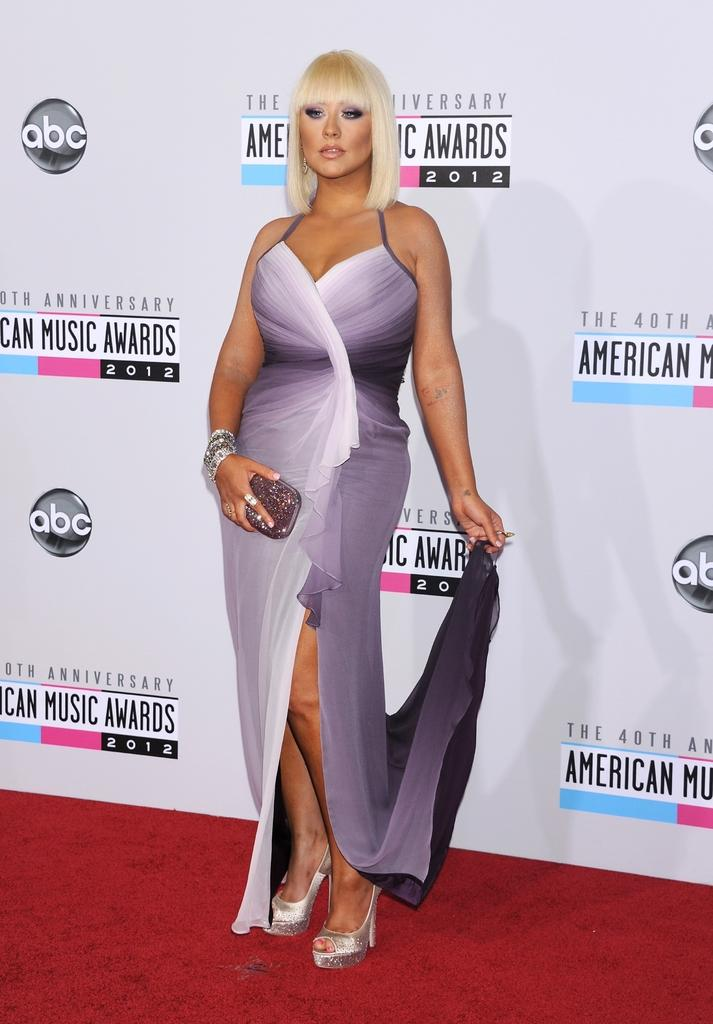Who is present in the image? There is a woman in the image. What is the woman standing on? The woman is standing on a carpet. What is the woman holding in her right hand? The woman is holding a wallet in her right hand. What can be seen in the background of the image? There is a hoarding in the background of the image. What type of church can be seen in the image? There is no church present in the image. Are there any ships visible in the image? There are no ships present in the image. 